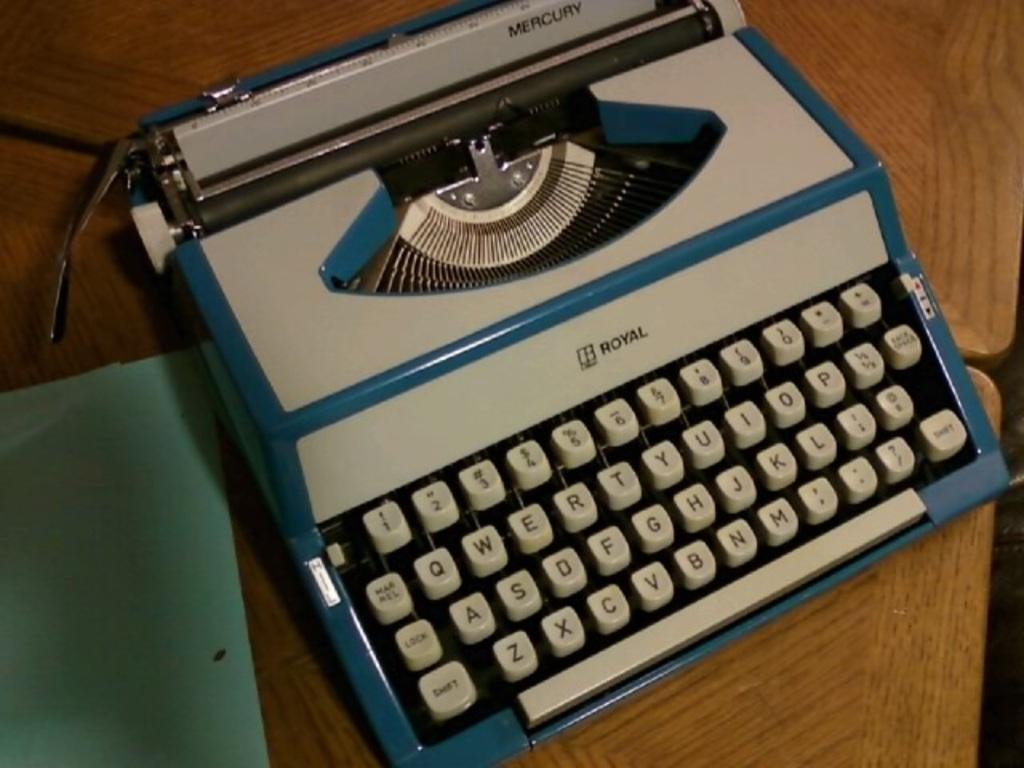Could you give a brief overview of what you see in this image? There is a typewriter machine on a wooden surface. Near to that there is a green color thing. 